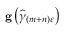Convert formula to latex. <formula><loc_0><loc_0><loc_500><loc_500>g \left ( \widehat { \gamma } _ { \left ( m + n \right ) \varepsilon } \right )</formula> 